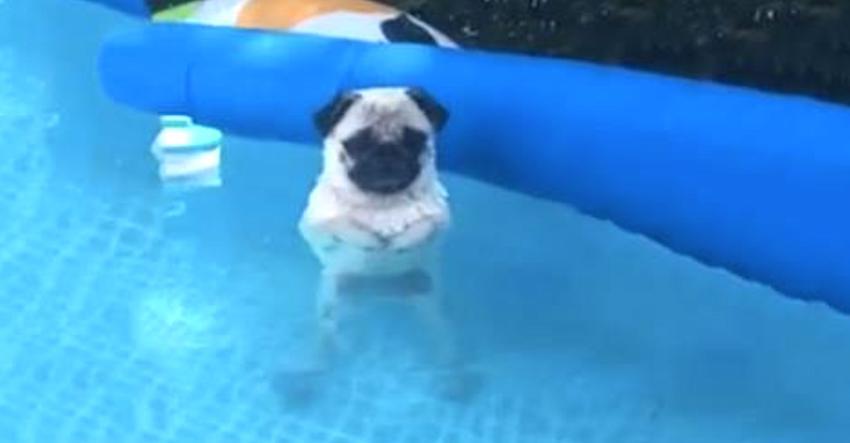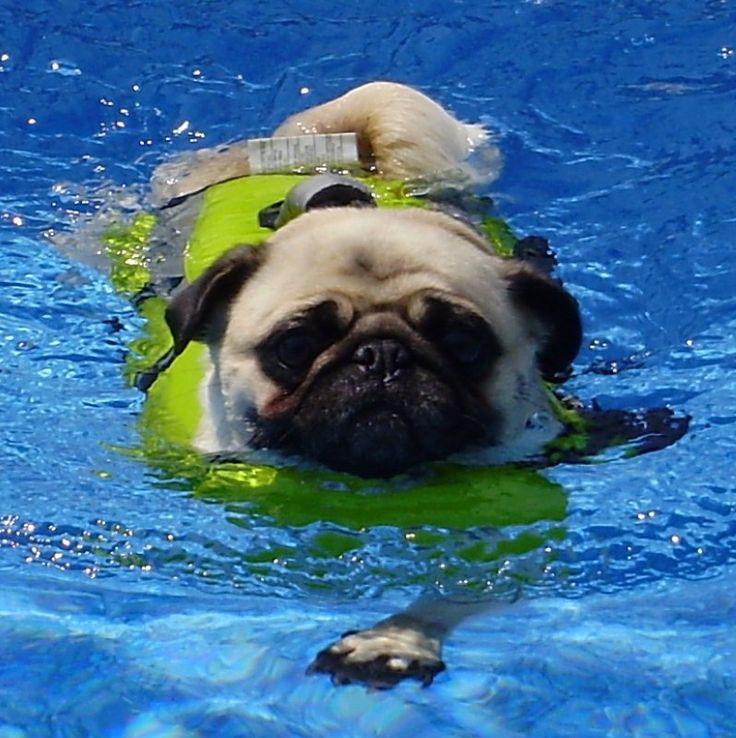The first image is the image on the left, the second image is the image on the right. For the images shown, is this caption "The pug in the left image is wearing a swimming vest." true? Answer yes or no. No. The first image is the image on the left, the second image is the image on the right. Examine the images to the left and right. Is the description "Only one pug is wearing a life vest." accurate? Answer yes or no. Yes. 